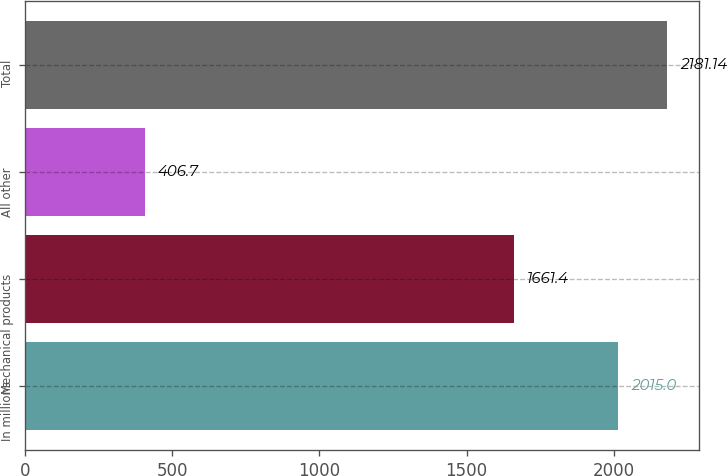Convert chart. <chart><loc_0><loc_0><loc_500><loc_500><bar_chart><fcel>In millions<fcel>Mechanical products<fcel>All other<fcel>Total<nl><fcel>2015<fcel>1661.4<fcel>406.7<fcel>2181.14<nl></chart> 